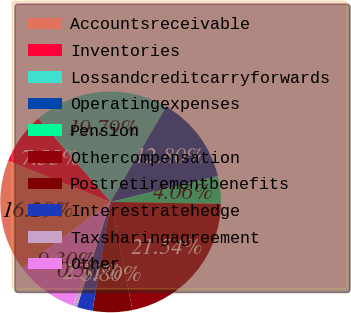<chart> <loc_0><loc_0><loc_500><loc_500><pie_chart><fcel>Accountsreceivable<fcel>Inventories<fcel>Lossandcreditcarryforwards<fcel>Operatingexpenses<fcel>Pension<fcel>Othercompensation<fcel>Postretirementbenefits<fcel>Interestratehedge<fcel>Taxsharingagreement<fcel>Other<nl><fcel>16.29%<fcel>7.55%<fcel>19.79%<fcel>12.8%<fcel>4.06%<fcel>21.54%<fcel>5.8%<fcel>2.31%<fcel>0.56%<fcel>9.3%<nl></chart> 